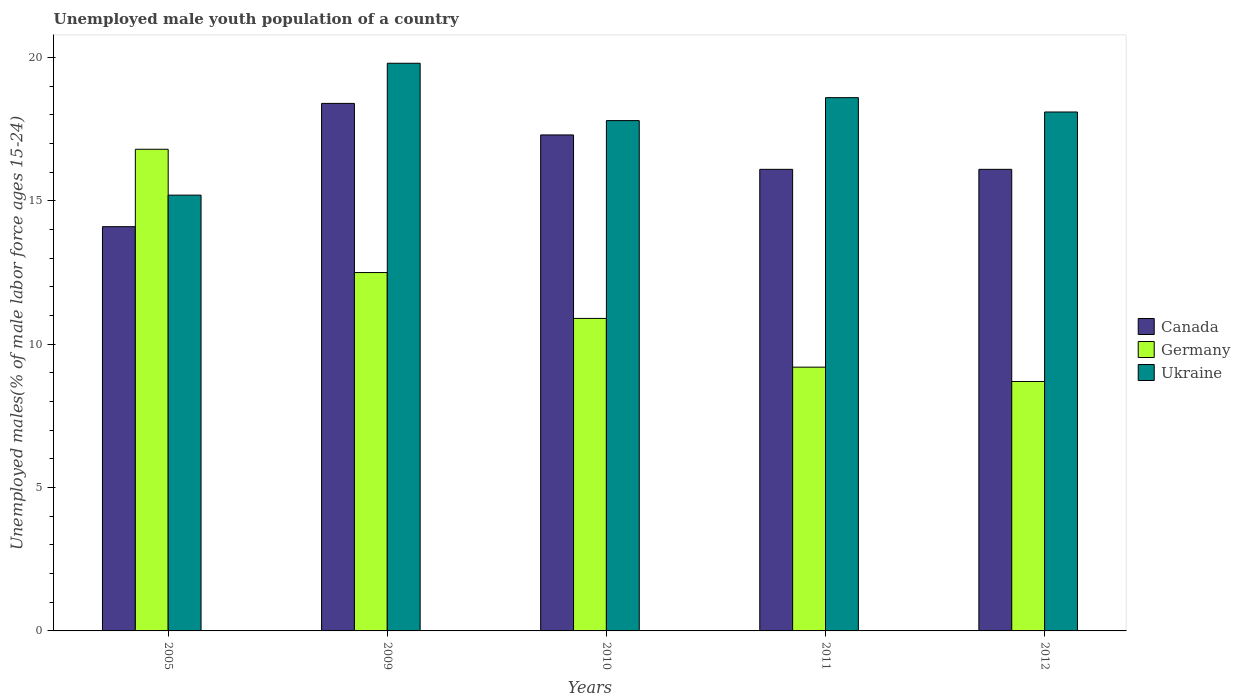How many different coloured bars are there?
Provide a short and direct response. 3. Are the number of bars per tick equal to the number of legend labels?
Make the answer very short. Yes. In how many cases, is the number of bars for a given year not equal to the number of legend labels?
Provide a succinct answer. 0. What is the percentage of unemployed male youth population in Ukraine in 2011?
Ensure brevity in your answer.  18.6. Across all years, what is the maximum percentage of unemployed male youth population in Germany?
Your answer should be compact. 16.8. Across all years, what is the minimum percentage of unemployed male youth population in Ukraine?
Give a very brief answer. 15.2. What is the total percentage of unemployed male youth population in Germany in the graph?
Keep it short and to the point. 58.1. What is the difference between the percentage of unemployed male youth population in Ukraine in 2009 and that in 2011?
Provide a short and direct response. 1.2. What is the difference between the percentage of unemployed male youth population in Canada in 2010 and the percentage of unemployed male youth population in Ukraine in 2012?
Ensure brevity in your answer.  -0.8. What is the average percentage of unemployed male youth population in Germany per year?
Ensure brevity in your answer.  11.62. In the year 2009, what is the difference between the percentage of unemployed male youth population in Canada and percentage of unemployed male youth population in Germany?
Make the answer very short. 5.9. In how many years, is the percentage of unemployed male youth population in Ukraine greater than 5 %?
Provide a short and direct response. 5. What is the ratio of the percentage of unemployed male youth population in Germany in 2009 to that in 2012?
Provide a succinct answer. 1.44. Is the percentage of unemployed male youth population in Ukraine in 2009 less than that in 2012?
Offer a terse response. No. Is the difference between the percentage of unemployed male youth population in Canada in 2005 and 2009 greater than the difference between the percentage of unemployed male youth population in Germany in 2005 and 2009?
Provide a short and direct response. No. What is the difference between the highest and the second highest percentage of unemployed male youth population in Ukraine?
Provide a short and direct response. 1.2. What is the difference between the highest and the lowest percentage of unemployed male youth population in Ukraine?
Keep it short and to the point. 4.6. What does the 2nd bar from the left in 2012 represents?
Ensure brevity in your answer.  Germany. What does the 1st bar from the right in 2010 represents?
Make the answer very short. Ukraine. Are all the bars in the graph horizontal?
Make the answer very short. No. Are the values on the major ticks of Y-axis written in scientific E-notation?
Offer a very short reply. No. Does the graph contain any zero values?
Give a very brief answer. No. Does the graph contain grids?
Offer a very short reply. No. Where does the legend appear in the graph?
Your response must be concise. Center right. How many legend labels are there?
Your response must be concise. 3. How are the legend labels stacked?
Offer a very short reply. Vertical. What is the title of the graph?
Offer a terse response. Unemployed male youth population of a country. What is the label or title of the X-axis?
Ensure brevity in your answer.  Years. What is the label or title of the Y-axis?
Offer a very short reply. Unemployed males(% of male labor force ages 15-24). What is the Unemployed males(% of male labor force ages 15-24) of Canada in 2005?
Make the answer very short. 14.1. What is the Unemployed males(% of male labor force ages 15-24) of Germany in 2005?
Provide a succinct answer. 16.8. What is the Unemployed males(% of male labor force ages 15-24) in Ukraine in 2005?
Keep it short and to the point. 15.2. What is the Unemployed males(% of male labor force ages 15-24) of Canada in 2009?
Keep it short and to the point. 18.4. What is the Unemployed males(% of male labor force ages 15-24) of Ukraine in 2009?
Give a very brief answer. 19.8. What is the Unemployed males(% of male labor force ages 15-24) of Canada in 2010?
Offer a very short reply. 17.3. What is the Unemployed males(% of male labor force ages 15-24) in Germany in 2010?
Make the answer very short. 10.9. What is the Unemployed males(% of male labor force ages 15-24) in Ukraine in 2010?
Provide a short and direct response. 17.8. What is the Unemployed males(% of male labor force ages 15-24) of Canada in 2011?
Offer a terse response. 16.1. What is the Unemployed males(% of male labor force ages 15-24) in Germany in 2011?
Provide a short and direct response. 9.2. What is the Unemployed males(% of male labor force ages 15-24) of Ukraine in 2011?
Ensure brevity in your answer.  18.6. What is the Unemployed males(% of male labor force ages 15-24) in Canada in 2012?
Ensure brevity in your answer.  16.1. What is the Unemployed males(% of male labor force ages 15-24) of Germany in 2012?
Offer a very short reply. 8.7. What is the Unemployed males(% of male labor force ages 15-24) in Ukraine in 2012?
Ensure brevity in your answer.  18.1. Across all years, what is the maximum Unemployed males(% of male labor force ages 15-24) of Canada?
Give a very brief answer. 18.4. Across all years, what is the maximum Unemployed males(% of male labor force ages 15-24) of Germany?
Keep it short and to the point. 16.8. Across all years, what is the maximum Unemployed males(% of male labor force ages 15-24) in Ukraine?
Provide a short and direct response. 19.8. Across all years, what is the minimum Unemployed males(% of male labor force ages 15-24) of Canada?
Keep it short and to the point. 14.1. Across all years, what is the minimum Unemployed males(% of male labor force ages 15-24) in Germany?
Keep it short and to the point. 8.7. Across all years, what is the minimum Unemployed males(% of male labor force ages 15-24) in Ukraine?
Offer a very short reply. 15.2. What is the total Unemployed males(% of male labor force ages 15-24) of Canada in the graph?
Offer a very short reply. 82. What is the total Unemployed males(% of male labor force ages 15-24) of Germany in the graph?
Your response must be concise. 58.1. What is the total Unemployed males(% of male labor force ages 15-24) in Ukraine in the graph?
Offer a very short reply. 89.5. What is the difference between the Unemployed males(% of male labor force ages 15-24) of Canada in 2005 and that in 2009?
Make the answer very short. -4.3. What is the difference between the Unemployed males(% of male labor force ages 15-24) of Ukraine in 2005 and that in 2009?
Your response must be concise. -4.6. What is the difference between the Unemployed males(% of male labor force ages 15-24) in Canada in 2005 and that in 2010?
Offer a very short reply. -3.2. What is the difference between the Unemployed males(% of male labor force ages 15-24) of Germany in 2005 and that in 2011?
Provide a short and direct response. 7.6. What is the difference between the Unemployed males(% of male labor force ages 15-24) of Ukraine in 2005 and that in 2011?
Provide a short and direct response. -3.4. What is the difference between the Unemployed males(% of male labor force ages 15-24) of Canada in 2005 and that in 2012?
Offer a terse response. -2. What is the difference between the Unemployed males(% of male labor force ages 15-24) of Ukraine in 2005 and that in 2012?
Provide a succinct answer. -2.9. What is the difference between the Unemployed males(% of male labor force ages 15-24) in Canada in 2009 and that in 2010?
Provide a short and direct response. 1.1. What is the difference between the Unemployed males(% of male labor force ages 15-24) of Germany in 2009 and that in 2010?
Keep it short and to the point. 1.6. What is the difference between the Unemployed males(% of male labor force ages 15-24) in Ukraine in 2009 and that in 2010?
Your response must be concise. 2. What is the difference between the Unemployed males(% of male labor force ages 15-24) of Canada in 2009 and that in 2011?
Provide a short and direct response. 2.3. What is the difference between the Unemployed males(% of male labor force ages 15-24) in Germany in 2009 and that in 2011?
Offer a terse response. 3.3. What is the difference between the Unemployed males(% of male labor force ages 15-24) of Canada in 2010 and that in 2011?
Offer a very short reply. 1.2. What is the difference between the Unemployed males(% of male labor force ages 15-24) of Germany in 2010 and that in 2011?
Provide a short and direct response. 1.7. What is the difference between the Unemployed males(% of male labor force ages 15-24) of Ukraine in 2010 and that in 2011?
Give a very brief answer. -0.8. What is the difference between the Unemployed males(% of male labor force ages 15-24) of Ukraine in 2010 and that in 2012?
Ensure brevity in your answer.  -0.3. What is the difference between the Unemployed males(% of male labor force ages 15-24) in Ukraine in 2011 and that in 2012?
Offer a terse response. 0.5. What is the difference between the Unemployed males(% of male labor force ages 15-24) in Canada in 2005 and the Unemployed males(% of male labor force ages 15-24) in Germany in 2009?
Offer a very short reply. 1.6. What is the difference between the Unemployed males(% of male labor force ages 15-24) of Canada in 2005 and the Unemployed males(% of male labor force ages 15-24) of Germany in 2010?
Make the answer very short. 3.2. What is the difference between the Unemployed males(% of male labor force ages 15-24) in Canada in 2005 and the Unemployed males(% of male labor force ages 15-24) in Ukraine in 2010?
Provide a short and direct response. -3.7. What is the difference between the Unemployed males(% of male labor force ages 15-24) in Canada in 2005 and the Unemployed males(% of male labor force ages 15-24) in Germany in 2011?
Your answer should be compact. 4.9. What is the difference between the Unemployed males(% of male labor force ages 15-24) of Germany in 2005 and the Unemployed males(% of male labor force ages 15-24) of Ukraine in 2011?
Your response must be concise. -1.8. What is the difference between the Unemployed males(% of male labor force ages 15-24) of Canada in 2005 and the Unemployed males(% of male labor force ages 15-24) of Ukraine in 2012?
Make the answer very short. -4. What is the difference between the Unemployed males(% of male labor force ages 15-24) in Germany in 2005 and the Unemployed males(% of male labor force ages 15-24) in Ukraine in 2012?
Give a very brief answer. -1.3. What is the difference between the Unemployed males(% of male labor force ages 15-24) in Canada in 2009 and the Unemployed males(% of male labor force ages 15-24) in Ukraine in 2011?
Your answer should be very brief. -0.2. What is the difference between the Unemployed males(% of male labor force ages 15-24) of Canada in 2009 and the Unemployed males(% of male labor force ages 15-24) of Germany in 2012?
Provide a short and direct response. 9.7. What is the difference between the Unemployed males(% of male labor force ages 15-24) of Canada in 2009 and the Unemployed males(% of male labor force ages 15-24) of Ukraine in 2012?
Keep it short and to the point. 0.3. What is the difference between the Unemployed males(% of male labor force ages 15-24) in Canada in 2010 and the Unemployed males(% of male labor force ages 15-24) in Germany in 2011?
Make the answer very short. 8.1. What is the difference between the Unemployed males(% of male labor force ages 15-24) of Germany in 2010 and the Unemployed males(% of male labor force ages 15-24) of Ukraine in 2012?
Ensure brevity in your answer.  -7.2. What is the difference between the Unemployed males(% of male labor force ages 15-24) of Canada in 2011 and the Unemployed males(% of male labor force ages 15-24) of Germany in 2012?
Your response must be concise. 7.4. What is the difference between the Unemployed males(% of male labor force ages 15-24) in Canada in 2011 and the Unemployed males(% of male labor force ages 15-24) in Ukraine in 2012?
Your response must be concise. -2. What is the difference between the Unemployed males(% of male labor force ages 15-24) in Germany in 2011 and the Unemployed males(% of male labor force ages 15-24) in Ukraine in 2012?
Make the answer very short. -8.9. What is the average Unemployed males(% of male labor force ages 15-24) in Canada per year?
Ensure brevity in your answer.  16.4. What is the average Unemployed males(% of male labor force ages 15-24) in Germany per year?
Your answer should be very brief. 11.62. What is the average Unemployed males(% of male labor force ages 15-24) in Ukraine per year?
Provide a short and direct response. 17.9. In the year 2005, what is the difference between the Unemployed males(% of male labor force ages 15-24) in Canada and Unemployed males(% of male labor force ages 15-24) in Germany?
Ensure brevity in your answer.  -2.7. In the year 2009, what is the difference between the Unemployed males(% of male labor force ages 15-24) in Canada and Unemployed males(% of male labor force ages 15-24) in Ukraine?
Provide a succinct answer. -1.4. In the year 2010, what is the difference between the Unemployed males(% of male labor force ages 15-24) in Canada and Unemployed males(% of male labor force ages 15-24) in Ukraine?
Offer a terse response. -0.5. In the year 2011, what is the difference between the Unemployed males(% of male labor force ages 15-24) of Germany and Unemployed males(% of male labor force ages 15-24) of Ukraine?
Offer a terse response. -9.4. In the year 2012, what is the difference between the Unemployed males(% of male labor force ages 15-24) in Canada and Unemployed males(% of male labor force ages 15-24) in Germany?
Keep it short and to the point. 7.4. In the year 2012, what is the difference between the Unemployed males(% of male labor force ages 15-24) in Canada and Unemployed males(% of male labor force ages 15-24) in Ukraine?
Offer a terse response. -2. In the year 2012, what is the difference between the Unemployed males(% of male labor force ages 15-24) of Germany and Unemployed males(% of male labor force ages 15-24) of Ukraine?
Your response must be concise. -9.4. What is the ratio of the Unemployed males(% of male labor force ages 15-24) in Canada in 2005 to that in 2009?
Your answer should be very brief. 0.77. What is the ratio of the Unemployed males(% of male labor force ages 15-24) of Germany in 2005 to that in 2009?
Offer a terse response. 1.34. What is the ratio of the Unemployed males(% of male labor force ages 15-24) of Ukraine in 2005 to that in 2009?
Offer a very short reply. 0.77. What is the ratio of the Unemployed males(% of male labor force ages 15-24) in Canada in 2005 to that in 2010?
Offer a terse response. 0.81. What is the ratio of the Unemployed males(% of male labor force ages 15-24) in Germany in 2005 to that in 2010?
Provide a short and direct response. 1.54. What is the ratio of the Unemployed males(% of male labor force ages 15-24) in Ukraine in 2005 to that in 2010?
Make the answer very short. 0.85. What is the ratio of the Unemployed males(% of male labor force ages 15-24) of Canada in 2005 to that in 2011?
Offer a very short reply. 0.88. What is the ratio of the Unemployed males(% of male labor force ages 15-24) in Germany in 2005 to that in 2011?
Provide a succinct answer. 1.83. What is the ratio of the Unemployed males(% of male labor force ages 15-24) of Ukraine in 2005 to that in 2011?
Provide a short and direct response. 0.82. What is the ratio of the Unemployed males(% of male labor force ages 15-24) in Canada in 2005 to that in 2012?
Keep it short and to the point. 0.88. What is the ratio of the Unemployed males(% of male labor force ages 15-24) in Germany in 2005 to that in 2012?
Your answer should be very brief. 1.93. What is the ratio of the Unemployed males(% of male labor force ages 15-24) in Ukraine in 2005 to that in 2012?
Your response must be concise. 0.84. What is the ratio of the Unemployed males(% of male labor force ages 15-24) of Canada in 2009 to that in 2010?
Give a very brief answer. 1.06. What is the ratio of the Unemployed males(% of male labor force ages 15-24) in Germany in 2009 to that in 2010?
Your response must be concise. 1.15. What is the ratio of the Unemployed males(% of male labor force ages 15-24) of Ukraine in 2009 to that in 2010?
Your answer should be compact. 1.11. What is the ratio of the Unemployed males(% of male labor force ages 15-24) in Canada in 2009 to that in 2011?
Your answer should be very brief. 1.14. What is the ratio of the Unemployed males(% of male labor force ages 15-24) of Germany in 2009 to that in 2011?
Give a very brief answer. 1.36. What is the ratio of the Unemployed males(% of male labor force ages 15-24) in Ukraine in 2009 to that in 2011?
Make the answer very short. 1.06. What is the ratio of the Unemployed males(% of male labor force ages 15-24) of Germany in 2009 to that in 2012?
Offer a terse response. 1.44. What is the ratio of the Unemployed males(% of male labor force ages 15-24) in Ukraine in 2009 to that in 2012?
Your response must be concise. 1.09. What is the ratio of the Unemployed males(% of male labor force ages 15-24) of Canada in 2010 to that in 2011?
Your response must be concise. 1.07. What is the ratio of the Unemployed males(% of male labor force ages 15-24) of Germany in 2010 to that in 2011?
Keep it short and to the point. 1.18. What is the ratio of the Unemployed males(% of male labor force ages 15-24) in Ukraine in 2010 to that in 2011?
Keep it short and to the point. 0.96. What is the ratio of the Unemployed males(% of male labor force ages 15-24) in Canada in 2010 to that in 2012?
Keep it short and to the point. 1.07. What is the ratio of the Unemployed males(% of male labor force ages 15-24) in Germany in 2010 to that in 2012?
Provide a short and direct response. 1.25. What is the ratio of the Unemployed males(% of male labor force ages 15-24) in Ukraine in 2010 to that in 2012?
Give a very brief answer. 0.98. What is the ratio of the Unemployed males(% of male labor force ages 15-24) of Canada in 2011 to that in 2012?
Make the answer very short. 1. What is the ratio of the Unemployed males(% of male labor force ages 15-24) in Germany in 2011 to that in 2012?
Give a very brief answer. 1.06. What is the ratio of the Unemployed males(% of male labor force ages 15-24) in Ukraine in 2011 to that in 2012?
Offer a terse response. 1.03. What is the difference between the highest and the second highest Unemployed males(% of male labor force ages 15-24) in Canada?
Your response must be concise. 1.1. What is the difference between the highest and the lowest Unemployed males(% of male labor force ages 15-24) in Germany?
Your answer should be very brief. 8.1. 